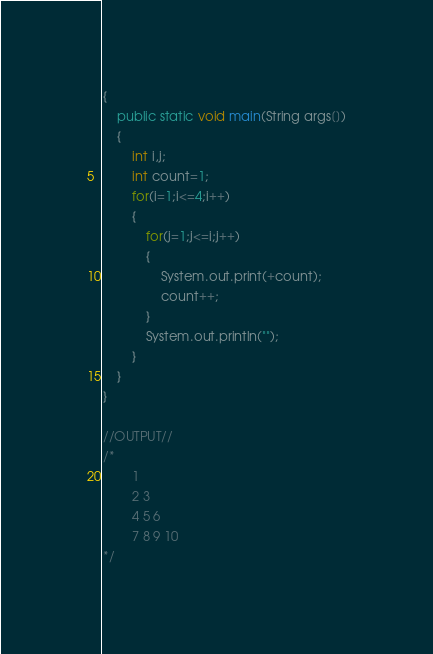<code> <loc_0><loc_0><loc_500><loc_500><_Java_>{
	public static void main(String args[])
	{
		int i,j;
		int count=1;
		for(i=1;i<=4;i++)
		{
			for(j=1;j<=i;j++)
			{
				System.out.print(+count);
				count++;
			}
			System.out.println("");
		}
	}
}

//OUTPUT//
/*
		1
		2 3
		4 5 6
		7 8 9 10
*/</code> 